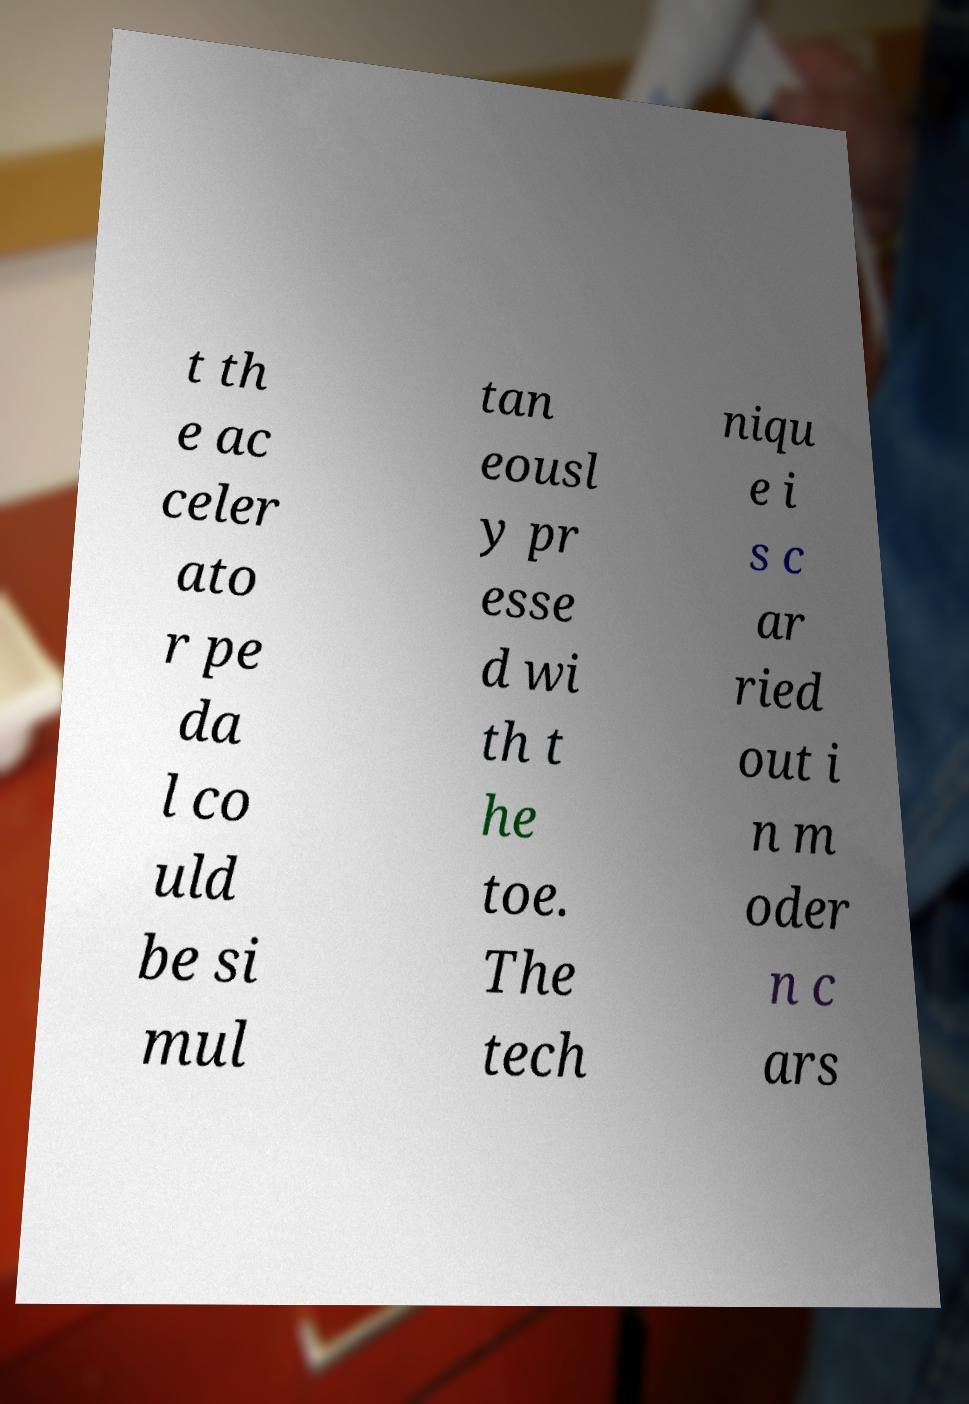Could you assist in decoding the text presented in this image and type it out clearly? t th e ac celer ato r pe da l co uld be si mul tan eousl y pr esse d wi th t he toe. The tech niqu e i s c ar ried out i n m oder n c ars 